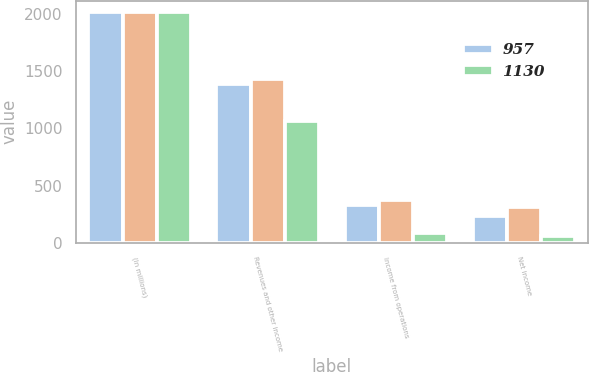<chart> <loc_0><loc_0><loc_500><loc_500><stacked_bar_chart><ecel><fcel>(In millions)<fcel>Revenues and other income<fcel>Income from operations<fcel>Net income<nl><fcel>957<fcel>2015<fcel>1390<fcel>332<fcel>239<nl><fcel>nan<fcel>2014<fcel>1430<fcel>379<fcel>316<nl><fcel>1130<fcel>2013<fcel>1067<fcel>87<fcel>63<nl></chart> 